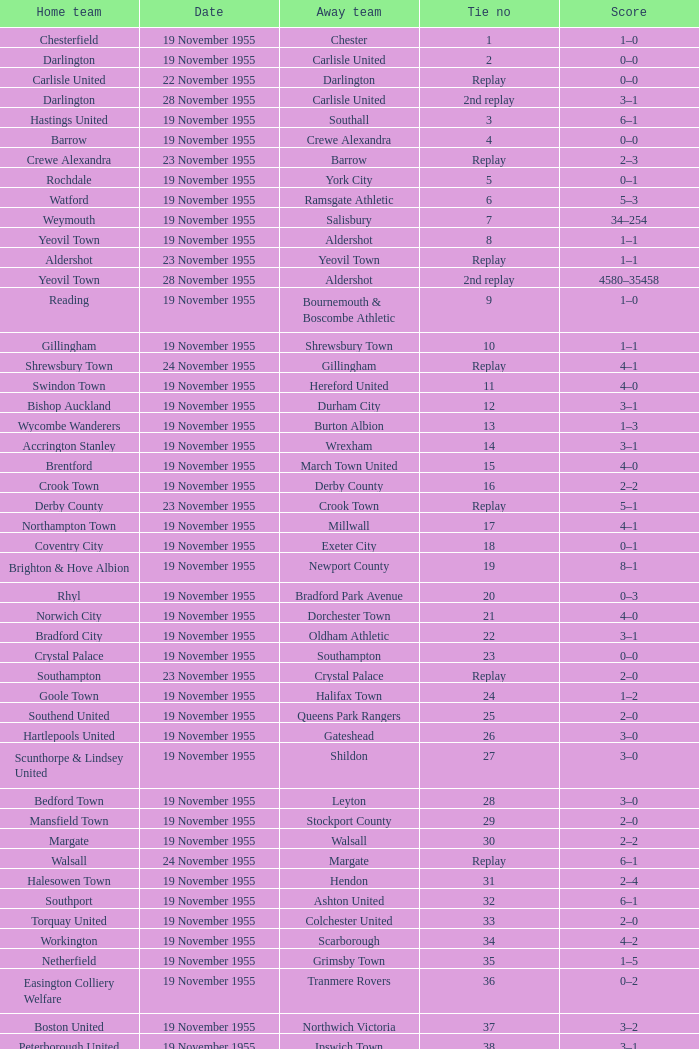What is the date of tie no. 34? 19 November 1955. 